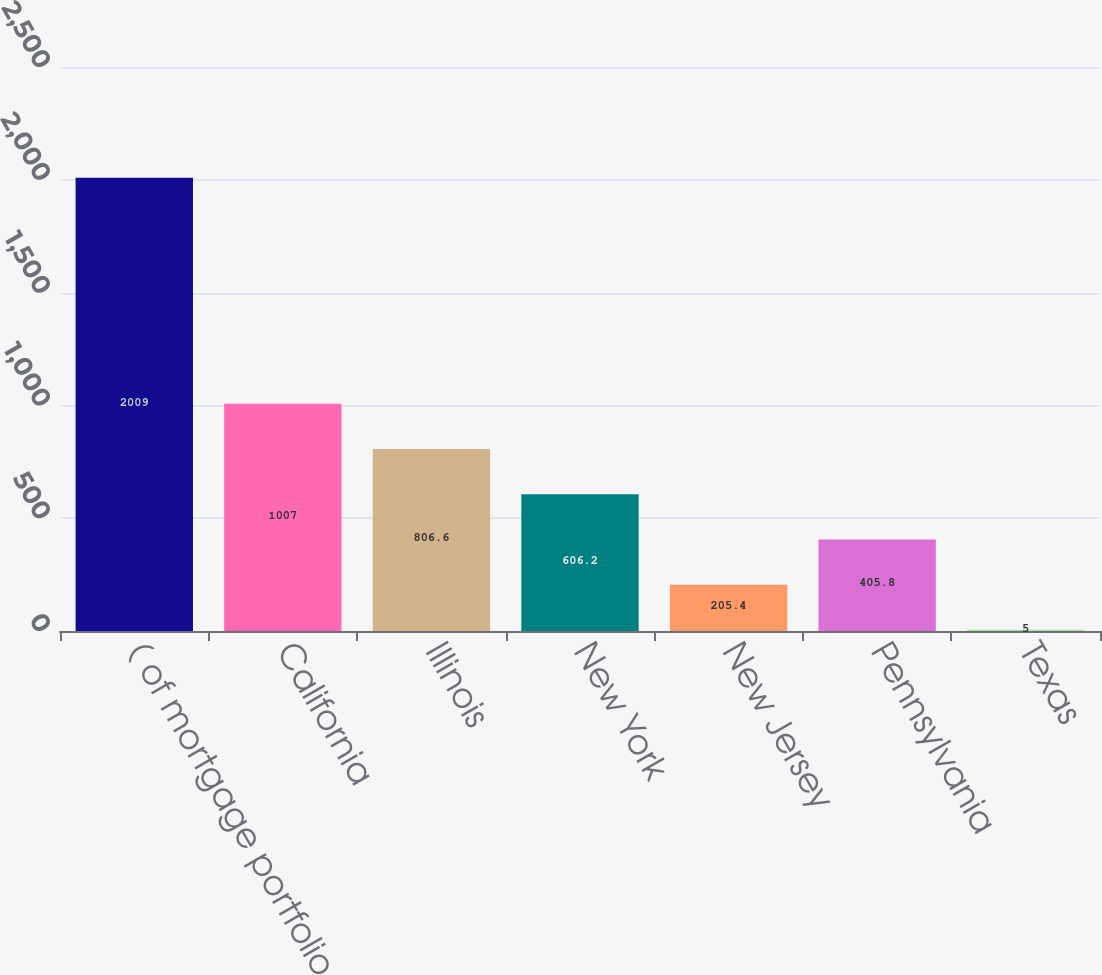Convert chart to OTSL. <chart><loc_0><loc_0><loc_500><loc_500><bar_chart><fcel>( of mortgage portfolio<fcel>California<fcel>Illinois<fcel>New York<fcel>New Jersey<fcel>Pennsylvania<fcel>Texas<nl><fcel>2009<fcel>1007<fcel>806.6<fcel>606.2<fcel>205.4<fcel>405.8<fcel>5<nl></chart> 